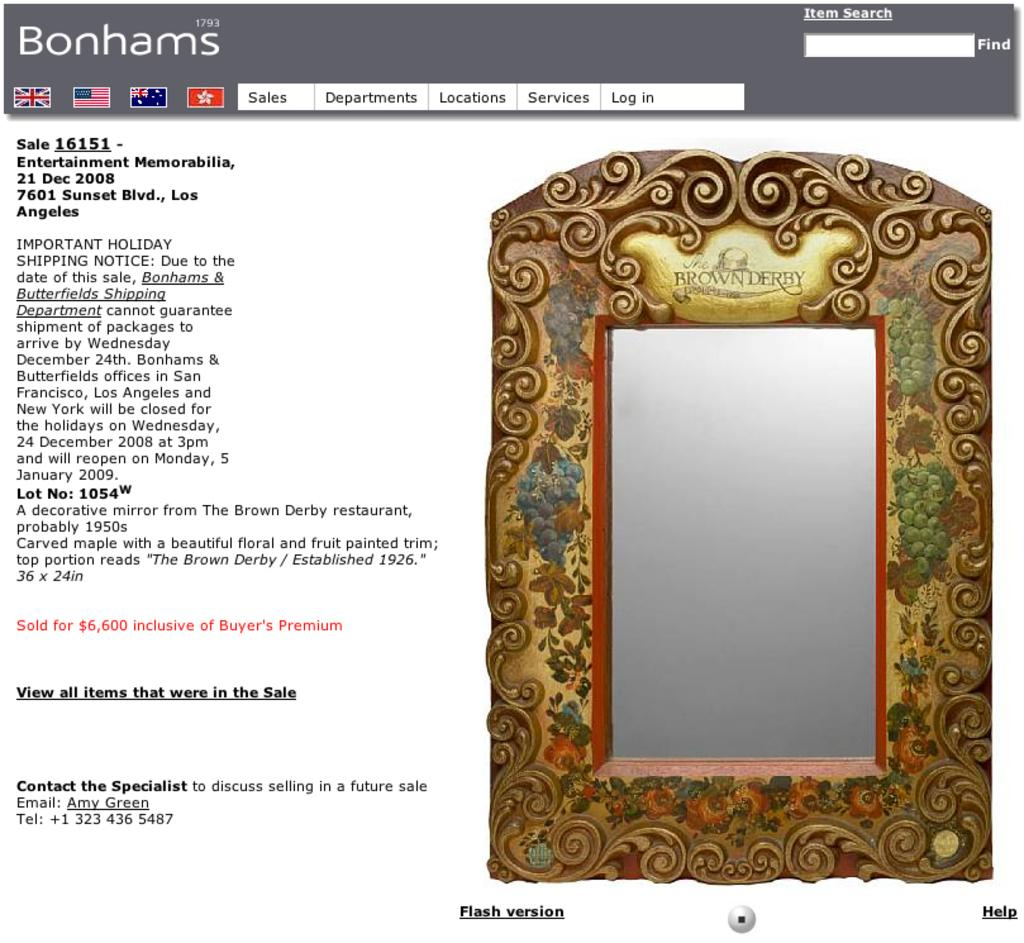What is the main subject of the image? The main subject of the image is a web page. What can be found on the web page? There is text and images on the web page. What type of apparatus is used to measure the leaf's dimensions in the image? There is no apparatus or leaf present in the image; it features a web page with text and images. What is the price of the item displayed on the web page? The image does not provide information about the price of any item displayed on the web page. 